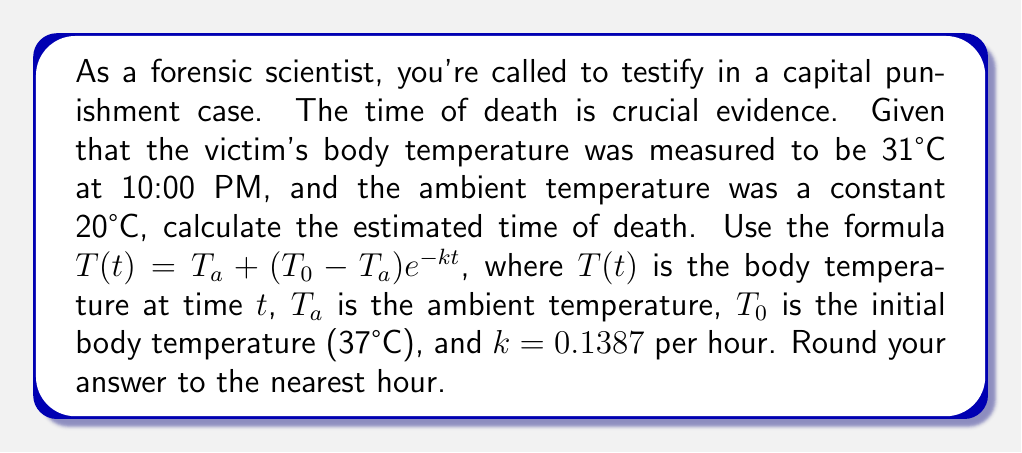Can you answer this question? To solve this problem, we'll use the given formula and information:

1) $T(t) = T_a + (T_0 - T_a)e^{-kt}$
   Where:
   $T(t) = 31°C$ (measured body temperature)
   $T_a = 20°C$ (ambient temperature)
   $T_0 = 37°C$ (initial body temperature)
   $k = 0.1387$ per hour

2) Substitute the known values into the equation:
   $31 = 20 + (37 - 20)e^{-0.1387t}$

3) Simplify:
   $31 = 20 + 17e^{-0.1387t}$

4) Subtract 20 from both sides:
   $11 = 17e^{-0.1387t}$

5) Divide both sides by 17:
   $\frac{11}{17} = e^{-0.1387t}$

6) Take the natural log of both sides:
   $\ln(\frac{11}{17}) = -0.1387t$

7) Divide both sides by -0.1387:
   $\frac{\ln(\frac{11}{17})}{-0.1387} = t$

8) Calculate:
   $t \approx 3.95$ hours

9) Round to the nearest hour:
   $t \approx 4$ hours

Therefore, the estimated time of death was approximately 4 hours before the body temperature was measured at 10:00 PM.
Answer: 6:00 PM 